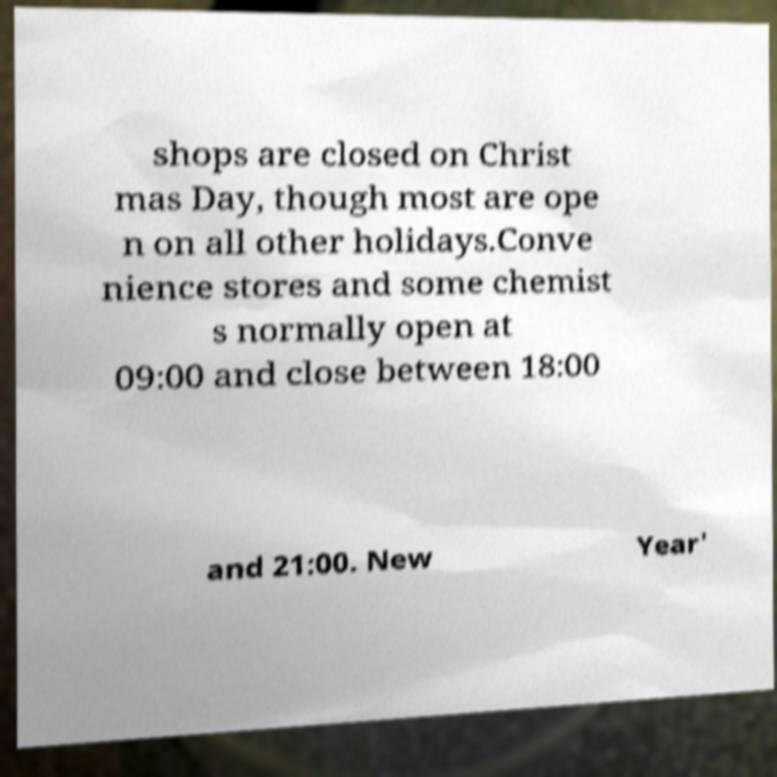What messages or text are displayed in this image? I need them in a readable, typed format. shops are closed on Christ mas Day, though most are ope n on all other holidays.Conve nience stores and some chemist s normally open at 09:00 and close between 18:00 and 21:00. New Year' 